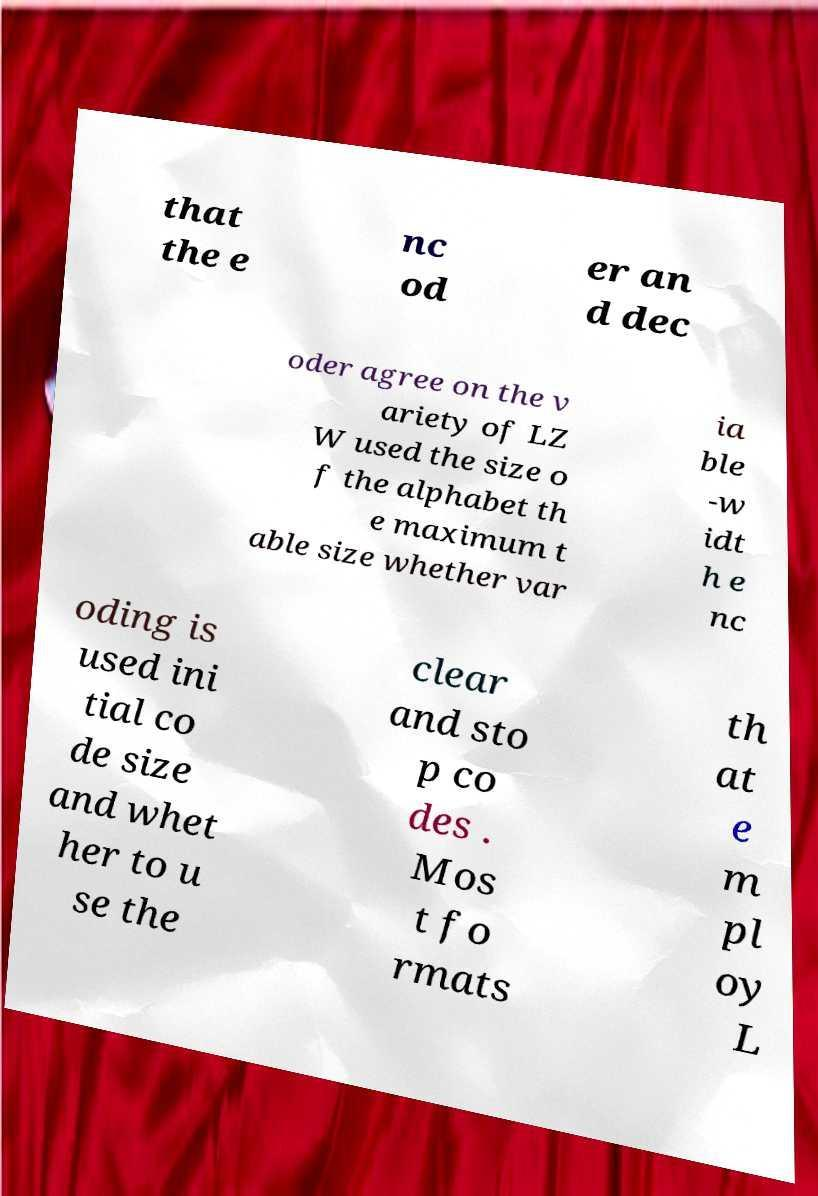Could you extract and type out the text from this image? that the e nc od er an d dec oder agree on the v ariety of LZ W used the size o f the alphabet th e maximum t able size whether var ia ble -w idt h e nc oding is used ini tial co de size and whet her to u se the clear and sto p co des . Mos t fo rmats th at e m pl oy L 